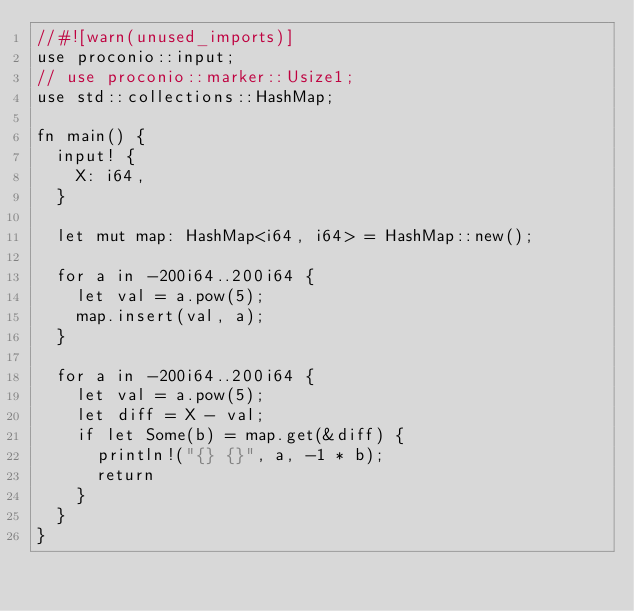<code> <loc_0><loc_0><loc_500><loc_500><_Rust_>//#![warn(unused_imports)]
use proconio::input;
// use proconio::marker::Usize1;
use std::collections::HashMap;

fn main() {
  input! {
    X: i64,
  }
  
  let mut map: HashMap<i64, i64> = HashMap::new();
  
  for a in -200i64..200i64 {
    let val = a.pow(5);
    map.insert(val, a);
  }
    
  for a in -200i64..200i64 {
    let val = a.pow(5);
    let diff = X - val;
    if let Some(b) = map.get(&diff) {
      println!("{} {}", a, -1 * b);
      return
    }  
  }
}</code> 